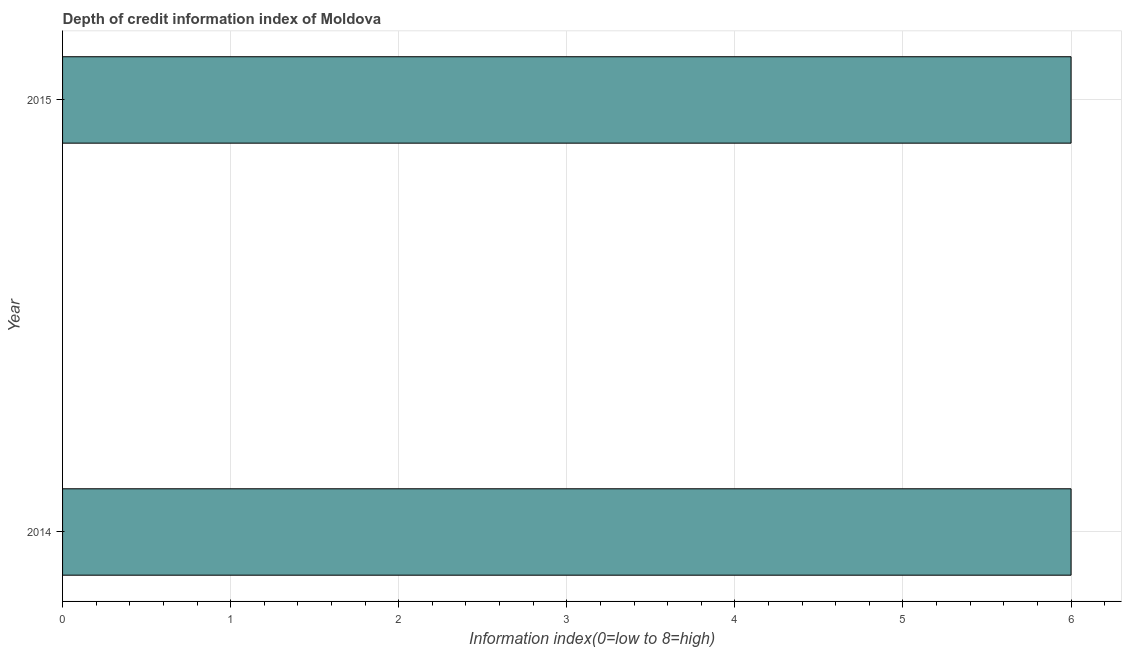Does the graph contain any zero values?
Provide a short and direct response. No. What is the title of the graph?
Your response must be concise. Depth of credit information index of Moldova. What is the label or title of the X-axis?
Offer a terse response. Information index(0=low to 8=high). What is the label or title of the Y-axis?
Your answer should be compact. Year. What is the depth of credit information index in 2014?
Ensure brevity in your answer.  6. In which year was the depth of credit information index maximum?
Provide a short and direct response. 2014. What is the sum of the depth of credit information index?
Keep it short and to the point. 12. What is the difference between the depth of credit information index in 2014 and 2015?
Your answer should be very brief. 0. What is the median depth of credit information index?
Keep it short and to the point. 6. Do a majority of the years between 2015 and 2014 (inclusive) have depth of credit information index greater than 2 ?
Provide a succinct answer. No. What is the ratio of the depth of credit information index in 2014 to that in 2015?
Your response must be concise. 1. Is the depth of credit information index in 2014 less than that in 2015?
Keep it short and to the point. No. How many bars are there?
Your answer should be very brief. 2. How many years are there in the graph?
Provide a succinct answer. 2. What is the difference between two consecutive major ticks on the X-axis?
Give a very brief answer. 1. Are the values on the major ticks of X-axis written in scientific E-notation?
Your answer should be compact. No. What is the difference between the Information index(0=low to 8=high) in 2014 and 2015?
Give a very brief answer. 0. 